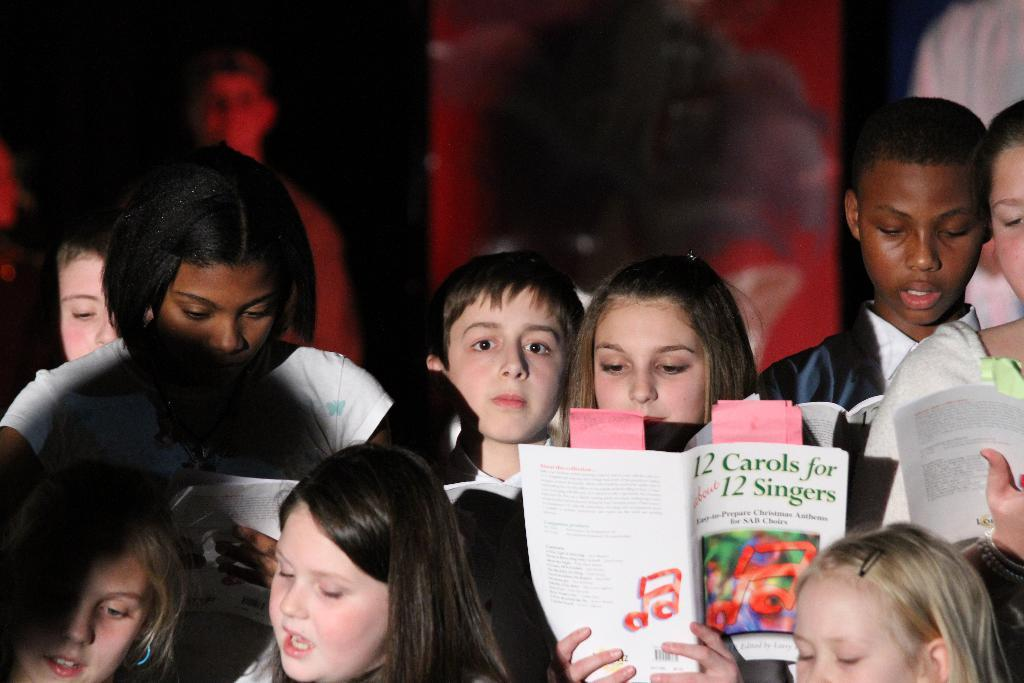What are the people in the image holding? The people in the image are holding books. Can you describe the background of the image? The background appears to be dark. Are there any other people visible in the image besides the ones holding books? Yes, there is a person visible in the background. What type of horn can be heard in the image? There is no horn present in the image, and therefore no sound can be heard. 